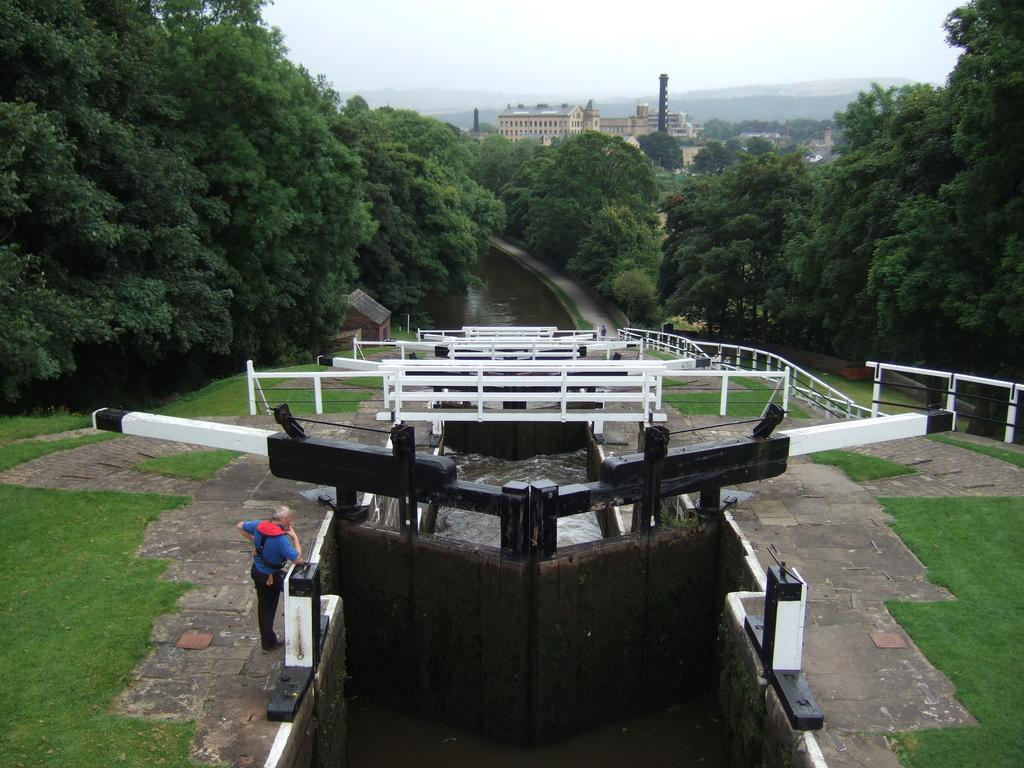What is the person in the image doing? The person is standing on the ground in the image. What natural element can be seen in the image? Water is visible in the image. What type of vegetation is present in the image? Trees are present in the image. What man-made structures can be seen in the image? There are buildings in the image. What geographical feature is visible in the image? Mountains are visible in the image. What is visible in the background of the image? The sky is visible in the background of the image. How many baby beds are visible in the image? There are no baby beds present in the image. What design is featured on the person's shirt in the image? The person's shirt design cannot be determined from the image. 